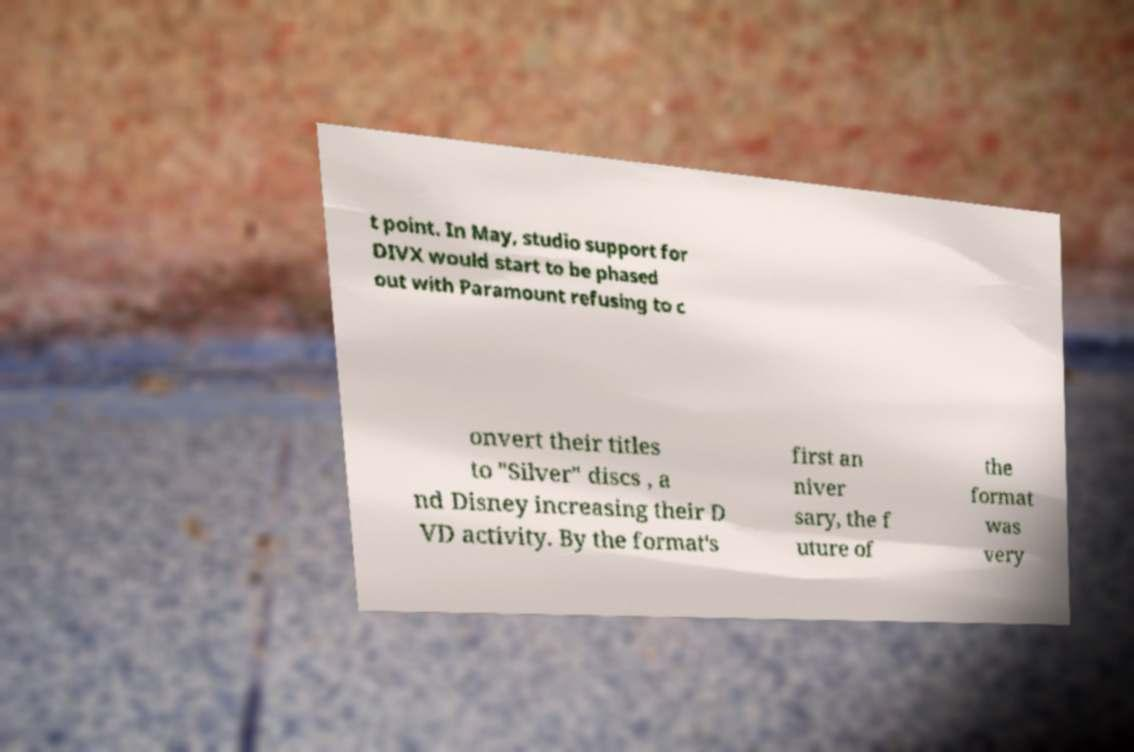I need the written content from this picture converted into text. Can you do that? t point. In May, studio support for DIVX would start to be phased out with Paramount refusing to c onvert their titles to "Silver" discs , a nd Disney increasing their D VD activity. By the format's first an niver sary, the f uture of the format was very 